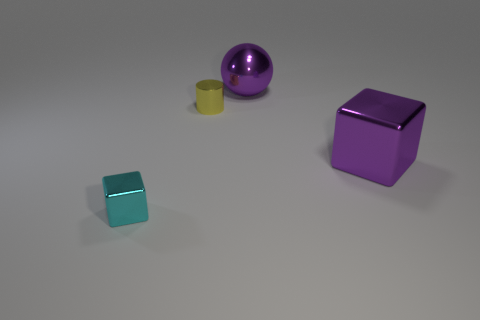Add 1 small cyan blocks. How many objects exist? 5 Subtract all cylinders. How many objects are left? 3 Subtract all small blue rubber balls. Subtract all big purple blocks. How many objects are left? 3 Add 1 tiny yellow shiny things. How many tiny yellow shiny things are left? 2 Add 2 tiny shiny blocks. How many tiny shiny blocks exist? 3 Subtract 0 cyan cylinders. How many objects are left? 4 